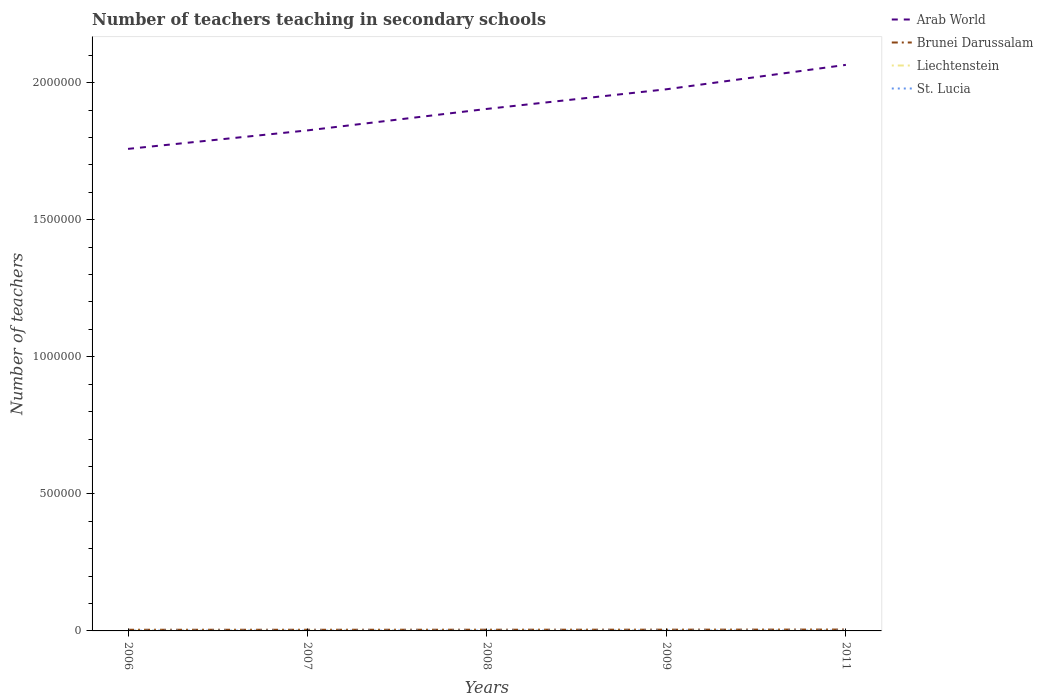Across all years, what is the maximum number of teachers teaching in secondary schools in Liechtenstein?
Your answer should be very brief. 309. In which year was the number of teachers teaching in secondary schools in Liechtenstein maximum?
Ensure brevity in your answer.  2011. What is the total number of teachers teaching in secondary schools in Brunei Darussalam in the graph?
Your response must be concise. -584. What is the difference between the highest and the second highest number of teachers teaching in secondary schools in Brunei Darussalam?
Provide a succinct answer. 768. Is the number of teachers teaching in secondary schools in Liechtenstein strictly greater than the number of teachers teaching in secondary schools in St. Lucia over the years?
Provide a succinct answer. Yes. What is the difference between two consecutive major ticks on the Y-axis?
Your response must be concise. 5.00e+05. Are the values on the major ticks of Y-axis written in scientific E-notation?
Make the answer very short. No. Does the graph contain any zero values?
Give a very brief answer. No. Does the graph contain grids?
Provide a short and direct response. No. How many legend labels are there?
Offer a terse response. 4. How are the legend labels stacked?
Make the answer very short. Vertical. What is the title of the graph?
Give a very brief answer. Number of teachers teaching in secondary schools. Does "Latvia" appear as one of the legend labels in the graph?
Keep it short and to the point. No. What is the label or title of the Y-axis?
Keep it short and to the point. Number of teachers. What is the Number of teachers of Arab World in 2006?
Give a very brief answer. 1.76e+06. What is the Number of teachers of Brunei Darussalam in 2006?
Offer a very short reply. 4255. What is the Number of teachers in Liechtenstein in 2006?
Your answer should be compact. 352. What is the Number of teachers of St. Lucia in 2006?
Offer a very short reply. 845. What is the Number of teachers of Arab World in 2007?
Provide a short and direct response. 1.83e+06. What is the Number of teachers of Brunei Darussalam in 2007?
Provide a short and direct response. 4274. What is the Number of teachers in Liechtenstein in 2007?
Keep it short and to the point. 369. What is the Number of teachers of St. Lucia in 2007?
Keep it short and to the point. 907. What is the Number of teachers in Arab World in 2008?
Offer a very short reply. 1.90e+06. What is the Number of teachers of Brunei Darussalam in 2008?
Ensure brevity in your answer.  4439. What is the Number of teachers of Liechtenstein in 2008?
Your answer should be very brief. 327. What is the Number of teachers in St. Lucia in 2008?
Your response must be concise. 979. What is the Number of teachers in Arab World in 2009?
Offer a very short reply. 1.98e+06. What is the Number of teachers of Brunei Darussalam in 2009?
Ensure brevity in your answer.  4601. What is the Number of teachers of Liechtenstein in 2009?
Your answer should be very brief. 339. What is the Number of teachers of St. Lucia in 2009?
Make the answer very short. 1002. What is the Number of teachers of Arab World in 2011?
Make the answer very short. 2.07e+06. What is the Number of teachers of Brunei Darussalam in 2011?
Offer a terse response. 5023. What is the Number of teachers in Liechtenstein in 2011?
Offer a terse response. 309. What is the Number of teachers of St. Lucia in 2011?
Offer a terse response. 1019. Across all years, what is the maximum Number of teachers of Arab World?
Ensure brevity in your answer.  2.07e+06. Across all years, what is the maximum Number of teachers of Brunei Darussalam?
Your response must be concise. 5023. Across all years, what is the maximum Number of teachers in Liechtenstein?
Provide a succinct answer. 369. Across all years, what is the maximum Number of teachers in St. Lucia?
Provide a succinct answer. 1019. Across all years, what is the minimum Number of teachers in Arab World?
Your answer should be very brief. 1.76e+06. Across all years, what is the minimum Number of teachers in Brunei Darussalam?
Your response must be concise. 4255. Across all years, what is the minimum Number of teachers of Liechtenstein?
Your answer should be compact. 309. Across all years, what is the minimum Number of teachers in St. Lucia?
Your response must be concise. 845. What is the total Number of teachers in Arab World in the graph?
Offer a very short reply. 9.53e+06. What is the total Number of teachers in Brunei Darussalam in the graph?
Give a very brief answer. 2.26e+04. What is the total Number of teachers in Liechtenstein in the graph?
Offer a terse response. 1696. What is the total Number of teachers of St. Lucia in the graph?
Offer a terse response. 4752. What is the difference between the Number of teachers in Arab World in 2006 and that in 2007?
Keep it short and to the point. -6.75e+04. What is the difference between the Number of teachers of St. Lucia in 2006 and that in 2007?
Your answer should be very brief. -62. What is the difference between the Number of teachers of Arab World in 2006 and that in 2008?
Your answer should be very brief. -1.46e+05. What is the difference between the Number of teachers in Brunei Darussalam in 2006 and that in 2008?
Your response must be concise. -184. What is the difference between the Number of teachers in St. Lucia in 2006 and that in 2008?
Offer a very short reply. -134. What is the difference between the Number of teachers of Arab World in 2006 and that in 2009?
Give a very brief answer. -2.18e+05. What is the difference between the Number of teachers of Brunei Darussalam in 2006 and that in 2009?
Your answer should be very brief. -346. What is the difference between the Number of teachers of St. Lucia in 2006 and that in 2009?
Ensure brevity in your answer.  -157. What is the difference between the Number of teachers of Arab World in 2006 and that in 2011?
Provide a short and direct response. -3.07e+05. What is the difference between the Number of teachers of Brunei Darussalam in 2006 and that in 2011?
Give a very brief answer. -768. What is the difference between the Number of teachers of Liechtenstein in 2006 and that in 2011?
Keep it short and to the point. 43. What is the difference between the Number of teachers in St. Lucia in 2006 and that in 2011?
Make the answer very short. -174. What is the difference between the Number of teachers in Arab World in 2007 and that in 2008?
Give a very brief answer. -7.84e+04. What is the difference between the Number of teachers of Brunei Darussalam in 2007 and that in 2008?
Provide a succinct answer. -165. What is the difference between the Number of teachers in Liechtenstein in 2007 and that in 2008?
Offer a terse response. 42. What is the difference between the Number of teachers in St. Lucia in 2007 and that in 2008?
Offer a very short reply. -72. What is the difference between the Number of teachers of Arab World in 2007 and that in 2009?
Offer a very short reply. -1.50e+05. What is the difference between the Number of teachers of Brunei Darussalam in 2007 and that in 2009?
Your answer should be compact. -327. What is the difference between the Number of teachers of St. Lucia in 2007 and that in 2009?
Ensure brevity in your answer.  -95. What is the difference between the Number of teachers in Arab World in 2007 and that in 2011?
Keep it short and to the point. -2.39e+05. What is the difference between the Number of teachers in Brunei Darussalam in 2007 and that in 2011?
Keep it short and to the point. -749. What is the difference between the Number of teachers in St. Lucia in 2007 and that in 2011?
Provide a succinct answer. -112. What is the difference between the Number of teachers of Arab World in 2008 and that in 2009?
Your answer should be compact. -7.16e+04. What is the difference between the Number of teachers in Brunei Darussalam in 2008 and that in 2009?
Your answer should be very brief. -162. What is the difference between the Number of teachers of St. Lucia in 2008 and that in 2009?
Ensure brevity in your answer.  -23. What is the difference between the Number of teachers in Arab World in 2008 and that in 2011?
Your answer should be very brief. -1.61e+05. What is the difference between the Number of teachers in Brunei Darussalam in 2008 and that in 2011?
Your answer should be compact. -584. What is the difference between the Number of teachers of St. Lucia in 2008 and that in 2011?
Offer a very short reply. -40. What is the difference between the Number of teachers of Arab World in 2009 and that in 2011?
Offer a terse response. -8.90e+04. What is the difference between the Number of teachers of Brunei Darussalam in 2009 and that in 2011?
Make the answer very short. -422. What is the difference between the Number of teachers in Arab World in 2006 and the Number of teachers in Brunei Darussalam in 2007?
Your answer should be compact. 1.75e+06. What is the difference between the Number of teachers of Arab World in 2006 and the Number of teachers of Liechtenstein in 2007?
Give a very brief answer. 1.76e+06. What is the difference between the Number of teachers in Arab World in 2006 and the Number of teachers in St. Lucia in 2007?
Provide a short and direct response. 1.76e+06. What is the difference between the Number of teachers of Brunei Darussalam in 2006 and the Number of teachers of Liechtenstein in 2007?
Offer a very short reply. 3886. What is the difference between the Number of teachers in Brunei Darussalam in 2006 and the Number of teachers in St. Lucia in 2007?
Offer a terse response. 3348. What is the difference between the Number of teachers of Liechtenstein in 2006 and the Number of teachers of St. Lucia in 2007?
Keep it short and to the point. -555. What is the difference between the Number of teachers of Arab World in 2006 and the Number of teachers of Brunei Darussalam in 2008?
Ensure brevity in your answer.  1.75e+06. What is the difference between the Number of teachers of Arab World in 2006 and the Number of teachers of Liechtenstein in 2008?
Offer a very short reply. 1.76e+06. What is the difference between the Number of teachers of Arab World in 2006 and the Number of teachers of St. Lucia in 2008?
Provide a short and direct response. 1.76e+06. What is the difference between the Number of teachers in Brunei Darussalam in 2006 and the Number of teachers in Liechtenstein in 2008?
Offer a very short reply. 3928. What is the difference between the Number of teachers in Brunei Darussalam in 2006 and the Number of teachers in St. Lucia in 2008?
Keep it short and to the point. 3276. What is the difference between the Number of teachers in Liechtenstein in 2006 and the Number of teachers in St. Lucia in 2008?
Provide a succinct answer. -627. What is the difference between the Number of teachers in Arab World in 2006 and the Number of teachers in Brunei Darussalam in 2009?
Your answer should be compact. 1.75e+06. What is the difference between the Number of teachers of Arab World in 2006 and the Number of teachers of Liechtenstein in 2009?
Provide a succinct answer. 1.76e+06. What is the difference between the Number of teachers in Arab World in 2006 and the Number of teachers in St. Lucia in 2009?
Your answer should be very brief. 1.76e+06. What is the difference between the Number of teachers of Brunei Darussalam in 2006 and the Number of teachers of Liechtenstein in 2009?
Offer a terse response. 3916. What is the difference between the Number of teachers of Brunei Darussalam in 2006 and the Number of teachers of St. Lucia in 2009?
Your response must be concise. 3253. What is the difference between the Number of teachers of Liechtenstein in 2006 and the Number of teachers of St. Lucia in 2009?
Your response must be concise. -650. What is the difference between the Number of teachers of Arab World in 2006 and the Number of teachers of Brunei Darussalam in 2011?
Your response must be concise. 1.75e+06. What is the difference between the Number of teachers of Arab World in 2006 and the Number of teachers of Liechtenstein in 2011?
Offer a terse response. 1.76e+06. What is the difference between the Number of teachers of Arab World in 2006 and the Number of teachers of St. Lucia in 2011?
Offer a terse response. 1.76e+06. What is the difference between the Number of teachers in Brunei Darussalam in 2006 and the Number of teachers in Liechtenstein in 2011?
Provide a short and direct response. 3946. What is the difference between the Number of teachers in Brunei Darussalam in 2006 and the Number of teachers in St. Lucia in 2011?
Your answer should be very brief. 3236. What is the difference between the Number of teachers of Liechtenstein in 2006 and the Number of teachers of St. Lucia in 2011?
Give a very brief answer. -667. What is the difference between the Number of teachers in Arab World in 2007 and the Number of teachers in Brunei Darussalam in 2008?
Offer a terse response. 1.82e+06. What is the difference between the Number of teachers of Arab World in 2007 and the Number of teachers of Liechtenstein in 2008?
Your answer should be compact. 1.83e+06. What is the difference between the Number of teachers in Arab World in 2007 and the Number of teachers in St. Lucia in 2008?
Keep it short and to the point. 1.83e+06. What is the difference between the Number of teachers of Brunei Darussalam in 2007 and the Number of teachers of Liechtenstein in 2008?
Offer a very short reply. 3947. What is the difference between the Number of teachers in Brunei Darussalam in 2007 and the Number of teachers in St. Lucia in 2008?
Offer a very short reply. 3295. What is the difference between the Number of teachers of Liechtenstein in 2007 and the Number of teachers of St. Lucia in 2008?
Offer a very short reply. -610. What is the difference between the Number of teachers of Arab World in 2007 and the Number of teachers of Brunei Darussalam in 2009?
Offer a very short reply. 1.82e+06. What is the difference between the Number of teachers of Arab World in 2007 and the Number of teachers of Liechtenstein in 2009?
Your answer should be very brief. 1.83e+06. What is the difference between the Number of teachers of Arab World in 2007 and the Number of teachers of St. Lucia in 2009?
Give a very brief answer. 1.83e+06. What is the difference between the Number of teachers in Brunei Darussalam in 2007 and the Number of teachers in Liechtenstein in 2009?
Provide a short and direct response. 3935. What is the difference between the Number of teachers in Brunei Darussalam in 2007 and the Number of teachers in St. Lucia in 2009?
Provide a succinct answer. 3272. What is the difference between the Number of teachers of Liechtenstein in 2007 and the Number of teachers of St. Lucia in 2009?
Offer a terse response. -633. What is the difference between the Number of teachers of Arab World in 2007 and the Number of teachers of Brunei Darussalam in 2011?
Ensure brevity in your answer.  1.82e+06. What is the difference between the Number of teachers of Arab World in 2007 and the Number of teachers of Liechtenstein in 2011?
Your answer should be very brief. 1.83e+06. What is the difference between the Number of teachers of Arab World in 2007 and the Number of teachers of St. Lucia in 2011?
Make the answer very short. 1.83e+06. What is the difference between the Number of teachers of Brunei Darussalam in 2007 and the Number of teachers of Liechtenstein in 2011?
Ensure brevity in your answer.  3965. What is the difference between the Number of teachers of Brunei Darussalam in 2007 and the Number of teachers of St. Lucia in 2011?
Your answer should be compact. 3255. What is the difference between the Number of teachers of Liechtenstein in 2007 and the Number of teachers of St. Lucia in 2011?
Keep it short and to the point. -650. What is the difference between the Number of teachers of Arab World in 2008 and the Number of teachers of Brunei Darussalam in 2009?
Your answer should be compact. 1.90e+06. What is the difference between the Number of teachers of Arab World in 2008 and the Number of teachers of Liechtenstein in 2009?
Provide a short and direct response. 1.90e+06. What is the difference between the Number of teachers in Arab World in 2008 and the Number of teachers in St. Lucia in 2009?
Offer a terse response. 1.90e+06. What is the difference between the Number of teachers in Brunei Darussalam in 2008 and the Number of teachers in Liechtenstein in 2009?
Make the answer very short. 4100. What is the difference between the Number of teachers of Brunei Darussalam in 2008 and the Number of teachers of St. Lucia in 2009?
Your response must be concise. 3437. What is the difference between the Number of teachers of Liechtenstein in 2008 and the Number of teachers of St. Lucia in 2009?
Offer a very short reply. -675. What is the difference between the Number of teachers of Arab World in 2008 and the Number of teachers of Brunei Darussalam in 2011?
Give a very brief answer. 1.90e+06. What is the difference between the Number of teachers of Arab World in 2008 and the Number of teachers of Liechtenstein in 2011?
Your answer should be very brief. 1.90e+06. What is the difference between the Number of teachers of Arab World in 2008 and the Number of teachers of St. Lucia in 2011?
Offer a very short reply. 1.90e+06. What is the difference between the Number of teachers in Brunei Darussalam in 2008 and the Number of teachers in Liechtenstein in 2011?
Provide a succinct answer. 4130. What is the difference between the Number of teachers of Brunei Darussalam in 2008 and the Number of teachers of St. Lucia in 2011?
Offer a very short reply. 3420. What is the difference between the Number of teachers of Liechtenstein in 2008 and the Number of teachers of St. Lucia in 2011?
Keep it short and to the point. -692. What is the difference between the Number of teachers in Arab World in 2009 and the Number of teachers in Brunei Darussalam in 2011?
Provide a succinct answer. 1.97e+06. What is the difference between the Number of teachers in Arab World in 2009 and the Number of teachers in Liechtenstein in 2011?
Provide a succinct answer. 1.98e+06. What is the difference between the Number of teachers in Arab World in 2009 and the Number of teachers in St. Lucia in 2011?
Offer a very short reply. 1.98e+06. What is the difference between the Number of teachers of Brunei Darussalam in 2009 and the Number of teachers of Liechtenstein in 2011?
Your answer should be very brief. 4292. What is the difference between the Number of teachers of Brunei Darussalam in 2009 and the Number of teachers of St. Lucia in 2011?
Offer a terse response. 3582. What is the difference between the Number of teachers of Liechtenstein in 2009 and the Number of teachers of St. Lucia in 2011?
Ensure brevity in your answer.  -680. What is the average Number of teachers in Arab World per year?
Your answer should be very brief. 1.91e+06. What is the average Number of teachers in Brunei Darussalam per year?
Your answer should be compact. 4518.4. What is the average Number of teachers of Liechtenstein per year?
Your answer should be compact. 339.2. What is the average Number of teachers in St. Lucia per year?
Give a very brief answer. 950.4. In the year 2006, what is the difference between the Number of teachers of Arab World and Number of teachers of Brunei Darussalam?
Keep it short and to the point. 1.75e+06. In the year 2006, what is the difference between the Number of teachers in Arab World and Number of teachers in Liechtenstein?
Ensure brevity in your answer.  1.76e+06. In the year 2006, what is the difference between the Number of teachers in Arab World and Number of teachers in St. Lucia?
Offer a terse response. 1.76e+06. In the year 2006, what is the difference between the Number of teachers of Brunei Darussalam and Number of teachers of Liechtenstein?
Provide a succinct answer. 3903. In the year 2006, what is the difference between the Number of teachers of Brunei Darussalam and Number of teachers of St. Lucia?
Offer a terse response. 3410. In the year 2006, what is the difference between the Number of teachers of Liechtenstein and Number of teachers of St. Lucia?
Keep it short and to the point. -493. In the year 2007, what is the difference between the Number of teachers in Arab World and Number of teachers in Brunei Darussalam?
Your answer should be very brief. 1.82e+06. In the year 2007, what is the difference between the Number of teachers in Arab World and Number of teachers in Liechtenstein?
Your response must be concise. 1.83e+06. In the year 2007, what is the difference between the Number of teachers in Arab World and Number of teachers in St. Lucia?
Your answer should be very brief. 1.83e+06. In the year 2007, what is the difference between the Number of teachers of Brunei Darussalam and Number of teachers of Liechtenstein?
Your response must be concise. 3905. In the year 2007, what is the difference between the Number of teachers in Brunei Darussalam and Number of teachers in St. Lucia?
Your answer should be very brief. 3367. In the year 2007, what is the difference between the Number of teachers of Liechtenstein and Number of teachers of St. Lucia?
Your answer should be very brief. -538. In the year 2008, what is the difference between the Number of teachers in Arab World and Number of teachers in Brunei Darussalam?
Provide a short and direct response. 1.90e+06. In the year 2008, what is the difference between the Number of teachers of Arab World and Number of teachers of Liechtenstein?
Ensure brevity in your answer.  1.90e+06. In the year 2008, what is the difference between the Number of teachers in Arab World and Number of teachers in St. Lucia?
Your answer should be compact. 1.90e+06. In the year 2008, what is the difference between the Number of teachers in Brunei Darussalam and Number of teachers in Liechtenstein?
Ensure brevity in your answer.  4112. In the year 2008, what is the difference between the Number of teachers in Brunei Darussalam and Number of teachers in St. Lucia?
Provide a succinct answer. 3460. In the year 2008, what is the difference between the Number of teachers of Liechtenstein and Number of teachers of St. Lucia?
Make the answer very short. -652. In the year 2009, what is the difference between the Number of teachers in Arab World and Number of teachers in Brunei Darussalam?
Ensure brevity in your answer.  1.97e+06. In the year 2009, what is the difference between the Number of teachers in Arab World and Number of teachers in Liechtenstein?
Keep it short and to the point. 1.98e+06. In the year 2009, what is the difference between the Number of teachers in Arab World and Number of teachers in St. Lucia?
Make the answer very short. 1.98e+06. In the year 2009, what is the difference between the Number of teachers of Brunei Darussalam and Number of teachers of Liechtenstein?
Provide a succinct answer. 4262. In the year 2009, what is the difference between the Number of teachers of Brunei Darussalam and Number of teachers of St. Lucia?
Your answer should be compact. 3599. In the year 2009, what is the difference between the Number of teachers in Liechtenstein and Number of teachers in St. Lucia?
Provide a short and direct response. -663. In the year 2011, what is the difference between the Number of teachers in Arab World and Number of teachers in Brunei Darussalam?
Offer a terse response. 2.06e+06. In the year 2011, what is the difference between the Number of teachers in Arab World and Number of teachers in Liechtenstein?
Your answer should be compact. 2.06e+06. In the year 2011, what is the difference between the Number of teachers of Arab World and Number of teachers of St. Lucia?
Offer a terse response. 2.06e+06. In the year 2011, what is the difference between the Number of teachers in Brunei Darussalam and Number of teachers in Liechtenstein?
Provide a succinct answer. 4714. In the year 2011, what is the difference between the Number of teachers of Brunei Darussalam and Number of teachers of St. Lucia?
Provide a short and direct response. 4004. In the year 2011, what is the difference between the Number of teachers of Liechtenstein and Number of teachers of St. Lucia?
Give a very brief answer. -710. What is the ratio of the Number of teachers in Arab World in 2006 to that in 2007?
Offer a terse response. 0.96. What is the ratio of the Number of teachers in Liechtenstein in 2006 to that in 2007?
Give a very brief answer. 0.95. What is the ratio of the Number of teachers in St. Lucia in 2006 to that in 2007?
Offer a very short reply. 0.93. What is the ratio of the Number of teachers of Arab World in 2006 to that in 2008?
Offer a terse response. 0.92. What is the ratio of the Number of teachers in Brunei Darussalam in 2006 to that in 2008?
Ensure brevity in your answer.  0.96. What is the ratio of the Number of teachers of Liechtenstein in 2006 to that in 2008?
Offer a terse response. 1.08. What is the ratio of the Number of teachers in St. Lucia in 2006 to that in 2008?
Provide a short and direct response. 0.86. What is the ratio of the Number of teachers in Arab World in 2006 to that in 2009?
Offer a very short reply. 0.89. What is the ratio of the Number of teachers of Brunei Darussalam in 2006 to that in 2009?
Keep it short and to the point. 0.92. What is the ratio of the Number of teachers in Liechtenstein in 2006 to that in 2009?
Ensure brevity in your answer.  1.04. What is the ratio of the Number of teachers in St. Lucia in 2006 to that in 2009?
Offer a very short reply. 0.84. What is the ratio of the Number of teachers in Arab World in 2006 to that in 2011?
Ensure brevity in your answer.  0.85. What is the ratio of the Number of teachers of Brunei Darussalam in 2006 to that in 2011?
Your answer should be very brief. 0.85. What is the ratio of the Number of teachers in Liechtenstein in 2006 to that in 2011?
Provide a short and direct response. 1.14. What is the ratio of the Number of teachers of St. Lucia in 2006 to that in 2011?
Offer a very short reply. 0.83. What is the ratio of the Number of teachers in Arab World in 2007 to that in 2008?
Offer a terse response. 0.96. What is the ratio of the Number of teachers in Brunei Darussalam in 2007 to that in 2008?
Your answer should be very brief. 0.96. What is the ratio of the Number of teachers in Liechtenstein in 2007 to that in 2008?
Your response must be concise. 1.13. What is the ratio of the Number of teachers in St. Lucia in 2007 to that in 2008?
Keep it short and to the point. 0.93. What is the ratio of the Number of teachers in Arab World in 2007 to that in 2009?
Your answer should be compact. 0.92. What is the ratio of the Number of teachers in Brunei Darussalam in 2007 to that in 2009?
Your response must be concise. 0.93. What is the ratio of the Number of teachers in Liechtenstein in 2007 to that in 2009?
Your answer should be compact. 1.09. What is the ratio of the Number of teachers of St. Lucia in 2007 to that in 2009?
Provide a short and direct response. 0.91. What is the ratio of the Number of teachers of Arab World in 2007 to that in 2011?
Offer a terse response. 0.88. What is the ratio of the Number of teachers in Brunei Darussalam in 2007 to that in 2011?
Ensure brevity in your answer.  0.85. What is the ratio of the Number of teachers of Liechtenstein in 2007 to that in 2011?
Your answer should be very brief. 1.19. What is the ratio of the Number of teachers of St. Lucia in 2007 to that in 2011?
Provide a succinct answer. 0.89. What is the ratio of the Number of teachers of Arab World in 2008 to that in 2009?
Offer a very short reply. 0.96. What is the ratio of the Number of teachers of Brunei Darussalam in 2008 to that in 2009?
Give a very brief answer. 0.96. What is the ratio of the Number of teachers in Liechtenstein in 2008 to that in 2009?
Ensure brevity in your answer.  0.96. What is the ratio of the Number of teachers in Arab World in 2008 to that in 2011?
Offer a terse response. 0.92. What is the ratio of the Number of teachers of Brunei Darussalam in 2008 to that in 2011?
Provide a short and direct response. 0.88. What is the ratio of the Number of teachers in Liechtenstein in 2008 to that in 2011?
Your response must be concise. 1.06. What is the ratio of the Number of teachers of St. Lucia in 2008 to that in 2011?
Offer a very short reply. 0.96. What is the ratio of the Number of teachers in Arab World in 2009 to that in 2011?
Ensure brevity in your answer.  0.96. What is the ratio of the Number of teachers in Brunei Darussalam in 2009 to that in 2011?
Your response must be concise. 0.92. What is the ratio of the Number of teachers of Liechtenstein in 2009 to that in 2011?
Keep it short and to the point. 1.1. What is the ratio of the Number of teachers in St. Lucia in 2009 to that in 2011?
Your answer should be compact. 0.98. What is the difference between the highest and the second highest Number of teachers of Arab World?
Your answer should be very brief. 8.90e+04. What is the difference between the highest and the second highest Number of teachers of Brunei Darussalam?
Ensure brevity in your answer.  422. What is the difference between the highest and the lowest Number of teachers of Arab World?
Offer a terse response. 3.07e+05. What is the difference between the highest and the lowest Number of teachers in Brunei Darussalam?
Offer a very short reply. 768. What is the difference between the highest and the lowest Number of teachers in Liechtenstein?
Your answer should be compact. 60. What is the difference between the highest and the lowest Number of teachers of St. Lucia?
Offer a terse response. 174. 